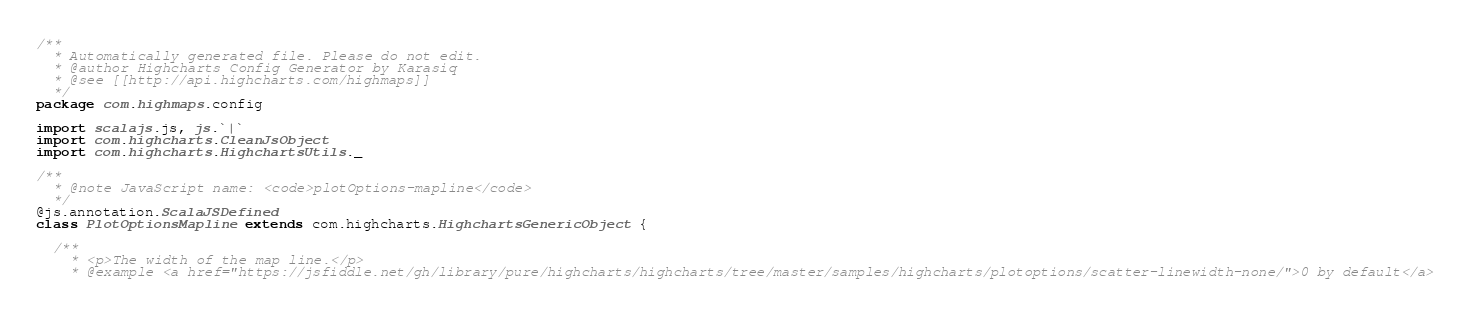<code> <loc_0><loc_0><loc_500><loc_500><_Scala_>/**
  * Automatically generated file. Please do not edit.
  * @author Highcharts Config Generator by Karasiq
  * @see [[http://api.highcharts.com/highmaps]]
  */
package com.highmaps.config

import scalajs.js, js.`|`
import com.highcharts.CleanJsObject
import com.highcharts.HighchartsUtils._

/**
  * @note JavaScript name: <code>plotOptions-mapline</code>
  */
@js.annotation.ScalaJSDefined
class PlotOptionsMapline extends com.highcharts.HighchartsGenericObject {

  /**
    * <p>The width of the map line.</p>
    * @example <a href="https://jsfiddle.net/gh/library/pure/highcharts/highcharts/tree/master/samples/highcharts/plotoptions/scatter-linewidth-none/">0 by default</a></code> 